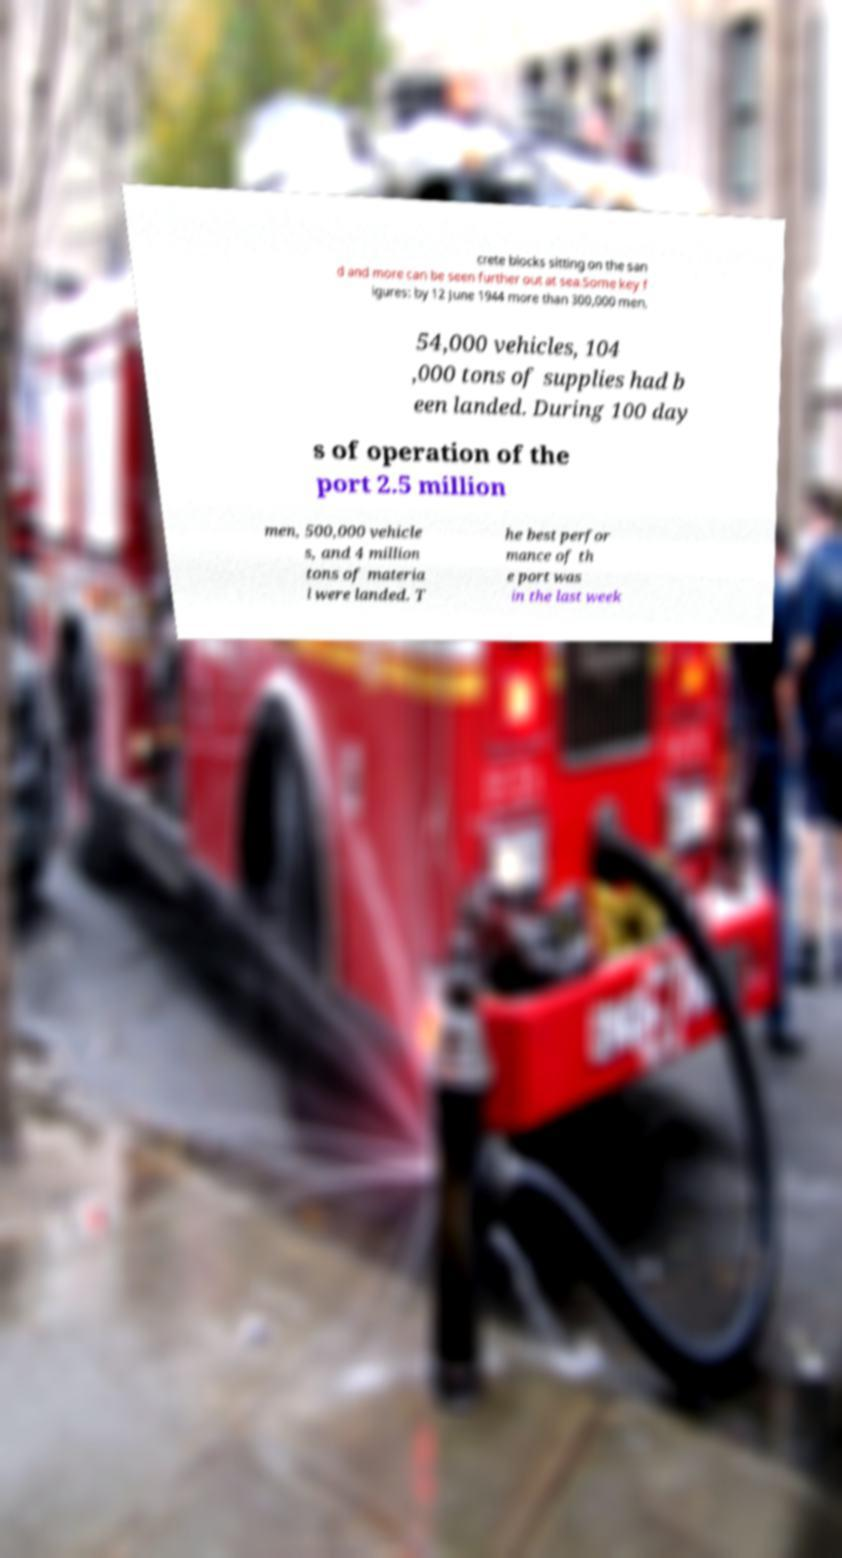For documentation purposes, I need the text within this image transcribed. Could you provide that? crete blocks sitting on the san d and more can be seen further out at sea.Some key f igures: by 12 June 1944 more than 300,000 men, 54,000 vehicles, 104 ,000 tons of supplies had b een landed. During 100 day s of operation of the port 2.5 million men, 500,000 vehicle s, and 4 million tons of materia l were landed. T he best perfor mance of th e port was in the last week 